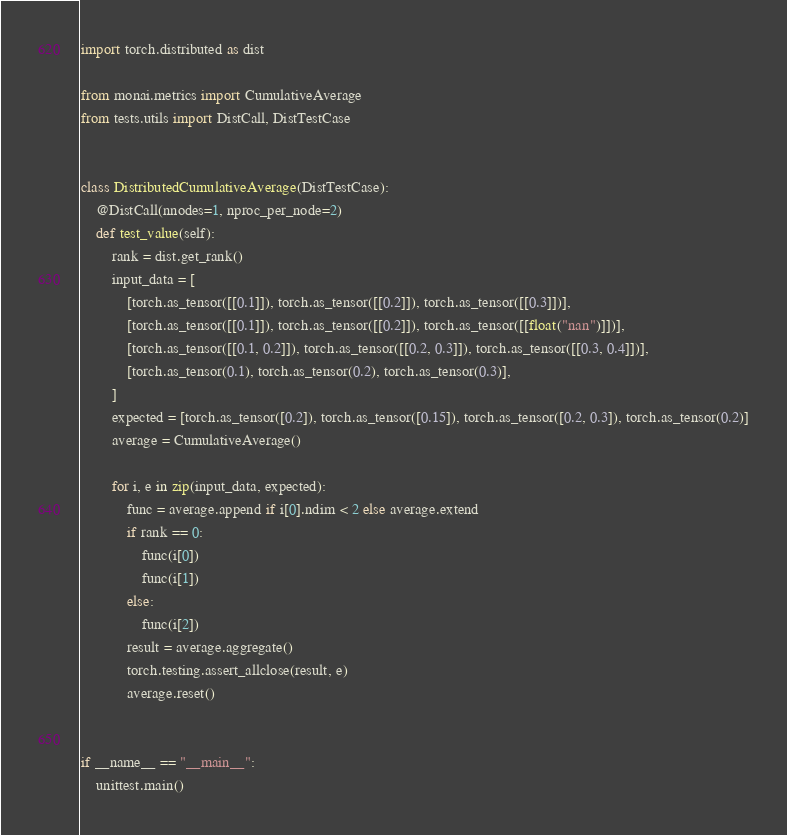<code> <loc_0><loc_0><loc_500><loc_500><_Python_>import torch.distributed as dist

from monai.metrics import CumulativeAverage
from tests.utils import DistCall, DistTestCase


class DistributedCumulativeAverage(DistTestCase):
    @DistCall(nnodes=1, nproc_per_node=2)
    def test_value(self):
        rank = dist.get_rank()
        input_data = [
            [torch.as_tensor([[0.1]]), torch.as_tensor([[0.2]]), torch.as_tensor([[0.3]])],
            [torch.as_tensor([[0.1]]), torch.as_tensor([[0.2]]), torch.as_tensor([[float("nan")]])],
            [torch.as_tensor([[0.1, 0.2]]), torch.as_tensor([[0.2, 0.3]]), torch.as_tensor([[0.3, 0.4]])],
            [torch.as_tensor(0.1), torch.as_tensor(0.2), torch.as_tensor(0.3)],
        ]
        expected = [torch.as_tensor([0.2]), torch.as_tensor([0.15]), torch.as_tensor([0.2, 0.3]), torch.as_tensor(0.2)]
        average = CumulativeAverage()

        for i, e in zip(input_data, expected):
            func = average.append if i[0].ndim < 2 else average.extend
            if rank == 0:
                func(i[0])
                func(i[1])
            else:
                func(i[2])
            result = average.aggregate()
            torch.testing.assert_allclose(result, e)
            average.reset()


if __name__ == "__main__":
    unittest.main()
</code> 